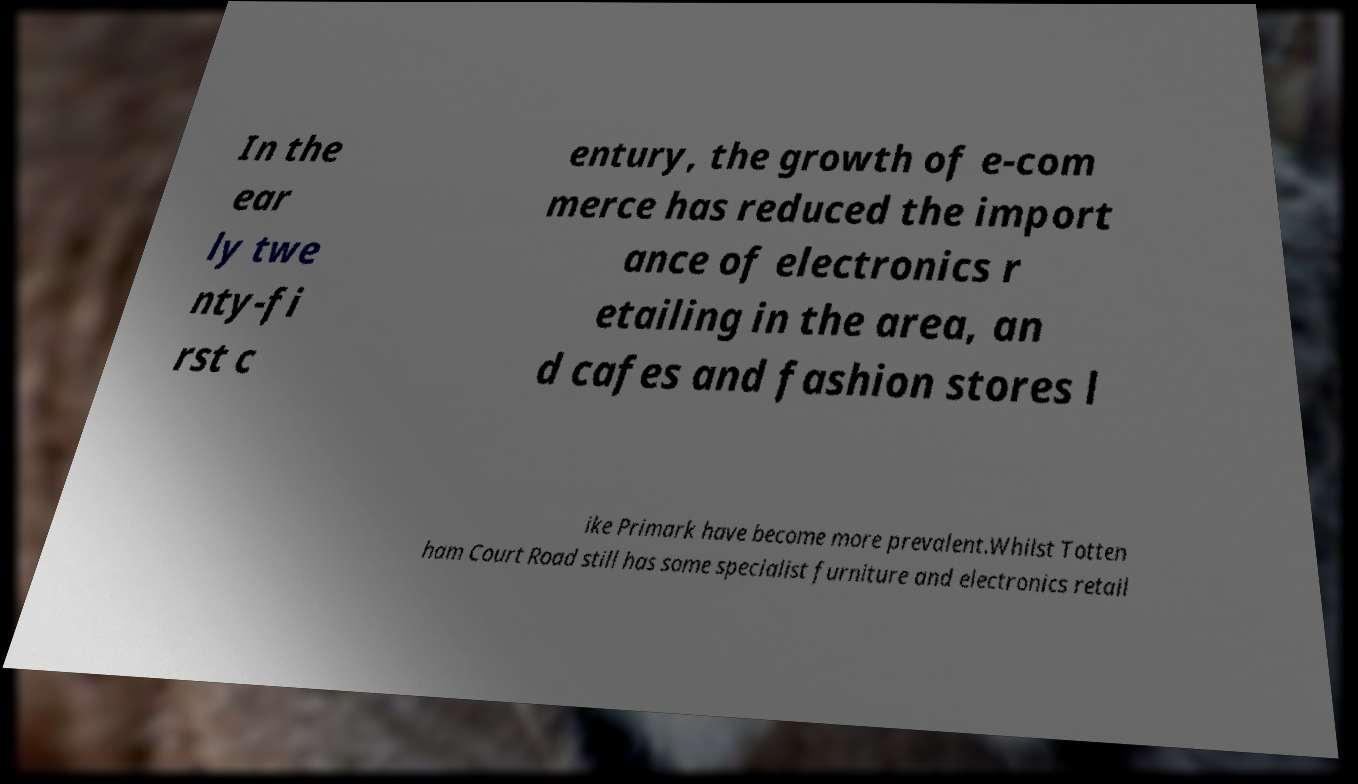Please read and relay the text visible in this image. What does it say? In the ear ly twe nty-fi rst c entury, the growth of e-com merce has reduced the import ance of electronics r etailing in the area, an d cafes and fashion stores l ike Primark have become more prevalent.Whilst Totten ham Court Road still has some specialist furniture and electronics retail 